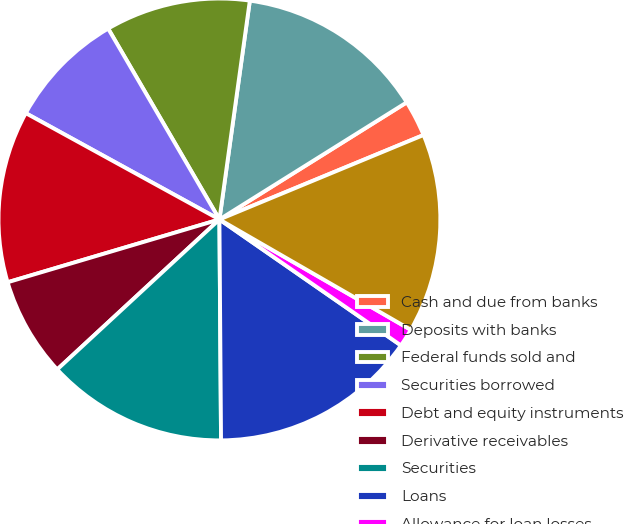Convert chart to OTSL. <chart><loc_0><loc_0><loc_500><loc_500><pie_chart><fcel>Cash and due from banks<fcel>Deposits with banks<fcel>Federal funds sold and<fcel>Securities borrowed<fcel>Debt and equity instruments<fcel>Derivative receivables<fcel>Securities<fcel>Loans<fcel>Allowance for loan losses<fcel>Loans net of allowance for<nl><fcel>2.65%<fcel>13.91%<fcel>10.6%<fcel>8.61%<fcel>12.58%<fcel>7.29%<fcel>13.24%<fcel>15.23%<fcel>1.33%<fcel>14.57%<nl></chart> 